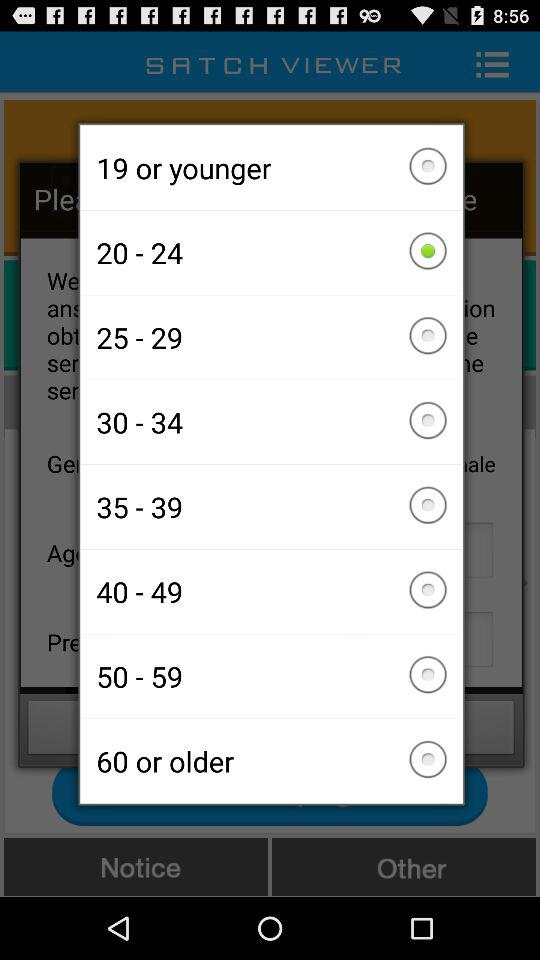How many age groups are there?
Answer the question using a single word or phrase. 8 